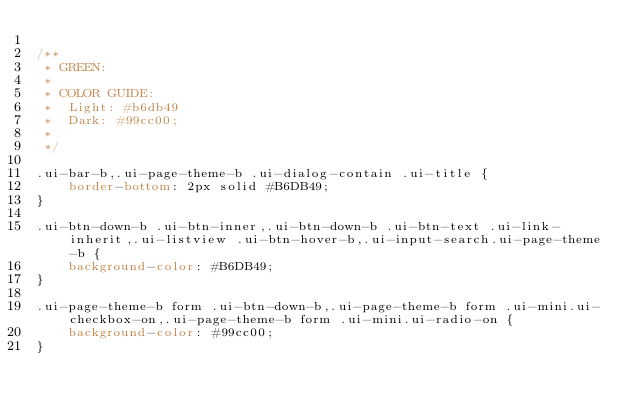Convert code to text. <code><loc_0><loc_0><loc_500><loc_500><_CSS_>
/**
 * GREEN:
 * 
 * COLOR GUIDE:
 * 	Light: #b6db49
 *  Dark: #99cc00;
 *
 */

.ui-bar-b,.ui-page-theme-b .ui-dialog-contain .ui-title {
	border-bottom: 2px solid #B6DB49;
}

.ui-btn-down-b .ui-btn-inner,.ui-btn-down-b .ui-btn-text .ui-link-inherit,.ui-listview .ui-btn-hover-b,.ui-input-search.ui-page-theme-b {
	background-color: #B6DB49;
}

.ui-page-theme-b form .ui-btn-down-b,.ui-page-theme-b form .ui-mini.ui-checkbox-on,.ui-page-theme-b form .ui-mini.ui-radio-on {
	background-color: #99cc00;
}

</code> 